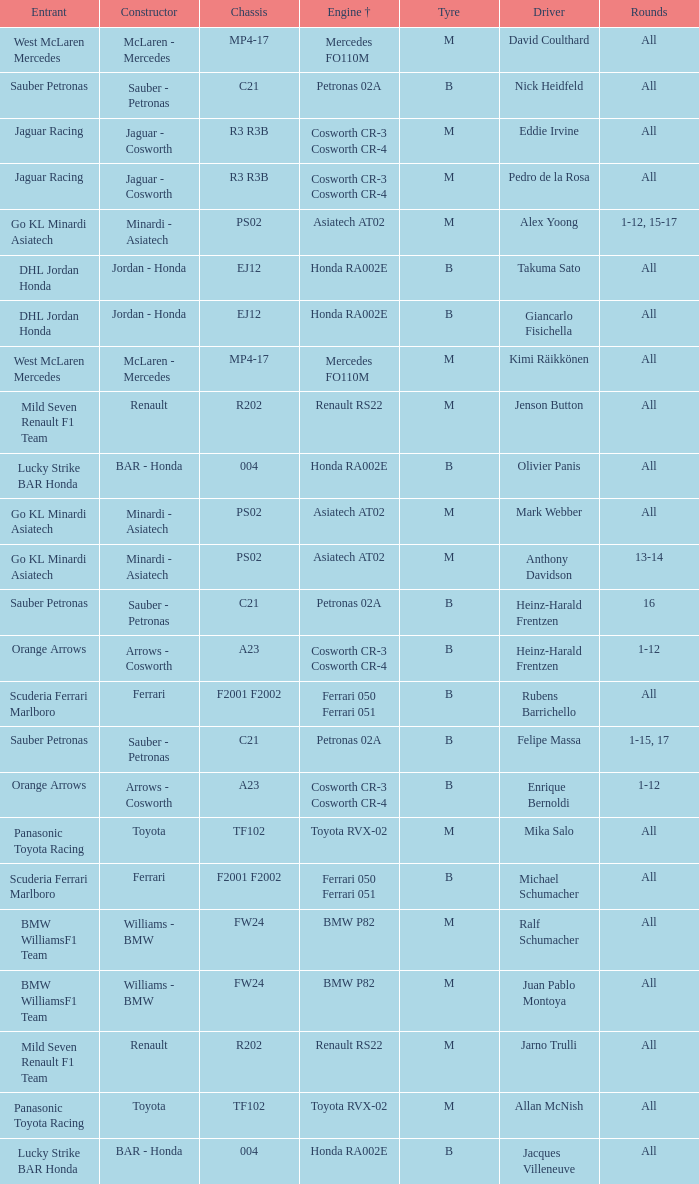What is the engine when the rounds ar all, the tyre is m and the driver is david coulthard? Mercedes FO110M. 